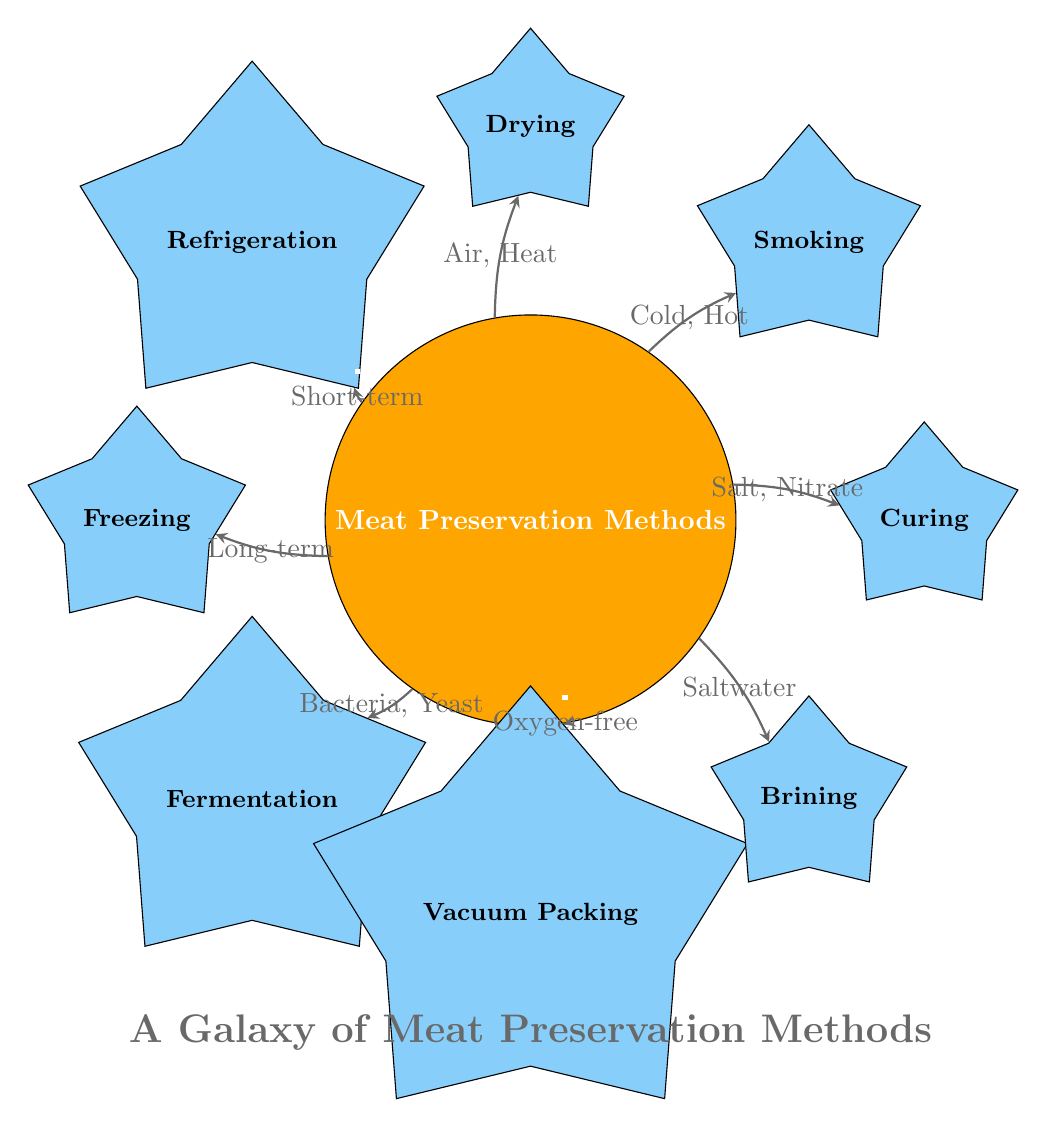What is the central node of the diagram? The central node is clearly labeled at the center of the diagram as "Meat Preservation Methods."
Answer: Meat Preservation Methods How many preservation methods are listed in the diagram? Counting the method nodes radiating from the central node, there are a total of eight preservation methods depicted in the diagram.
Answer: 8 What relationship is associated with the Smoking method? The relationship indicated for the Smoking method shows the types of conditions needed, which are labeled as "Cold, Hot."
Answer: Cold, Hot Which preservation method requires "Oxygen-free" conditions? The Vacuum Packing method is specifically associated with the label "Oxygen-free," indicating the environment needed for this method.
Answer: Vacuum Packing Which two preservation methods utilize salt in their processes? The Curing method requires "Salt, Nitrate" and the Brining method requires "Saltwater," making them the two methods that use salt.
Answer: Curing, Brining Which method is primarily for long-term storage? The diagram specifies the method associated with long-term preservation as "Freezing."
Answer: Freezing What is the primary agent used for Fermentation? The required agents for the Fermentation method are labelled as "Bacteria, Yeast," which are essential for the fermentation process.
Answer: Bacteria, Yeast How does Drying preserve meat? The relationship associated with the Drying method involves "Air, Heat," which are crucial elements for the drying process and help inhibit spoilage.
Answer: Air, Heat Which preservation method would you choose for a short-term solution? The preservation method designated for short-term use is listed as "Refrigeration," according to the relationship in the diagram.
Answer: Refrigeration 